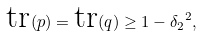<formula> <loc_0><loc_0><loc_500><loc_500>\text {tr} ( p ) = \text {tr} ( q ) \geq 1 - { \delta _ { 2 } } ^ { 2 } ,</formula> 